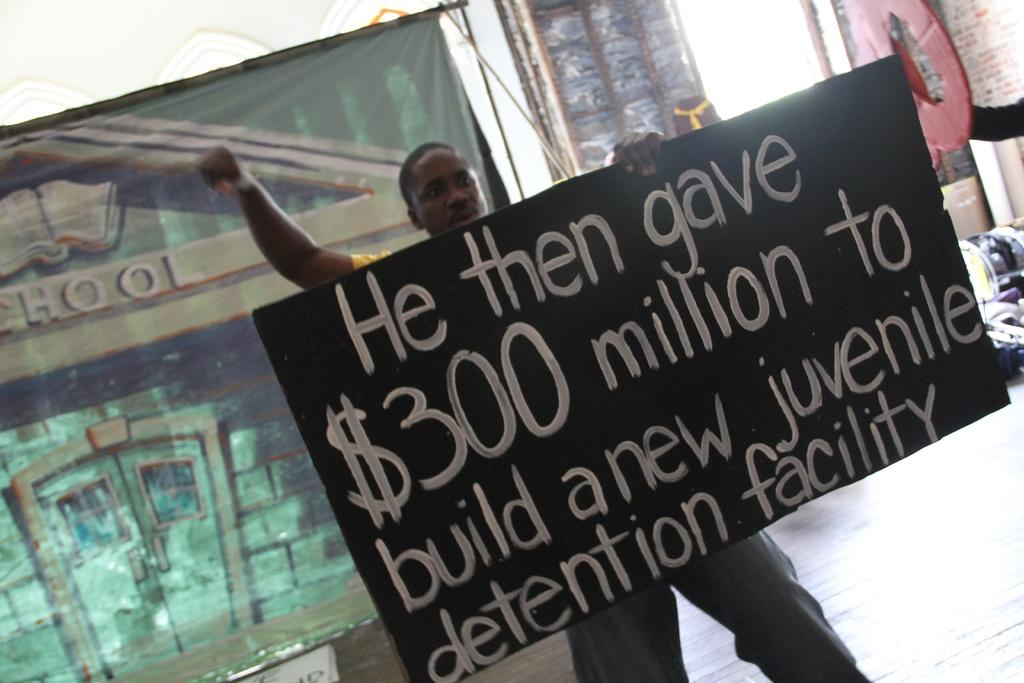What is the person in the image holding? The person is holding a board in the image. What can be seen on the board? There is text on the board. What is visible in the background of the image? There is a banner, a floor, a wall, and objects in the background of the image. What type of oatmeal is being served in the hospital depicted in the image? There is no hospital or oatmeal present in the image. The image features a person holding a board with text, and the background includes a banner, floor, wall, and other objects. 